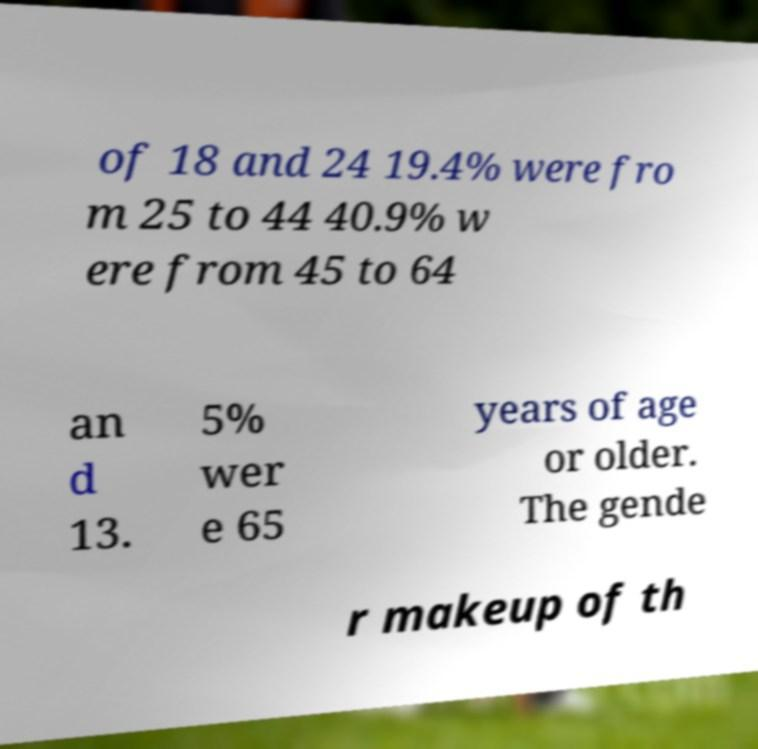Please identify and transcribe the text found in this image. of 18 and 24 19.4% were fro m 25 to 44 40.9% w ere from 45 to 64 an d 13. 5% wer e 65 years of age or older. The gende r makeup of th 